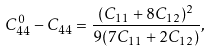Convert formula to latex. <formula><loc_0><loc_0><loc_500><loc_500>C _ { 4 4 } ^ { 0 } - C _ { 4 4 } = \frac { ( C _ { 1 1 } + 8 C _ { 1 2 } ) ^ { 2 } } { 9 ( 7 C _ { 1 1 } + 2 C _ { 1 2 } ) } ,</formula> 